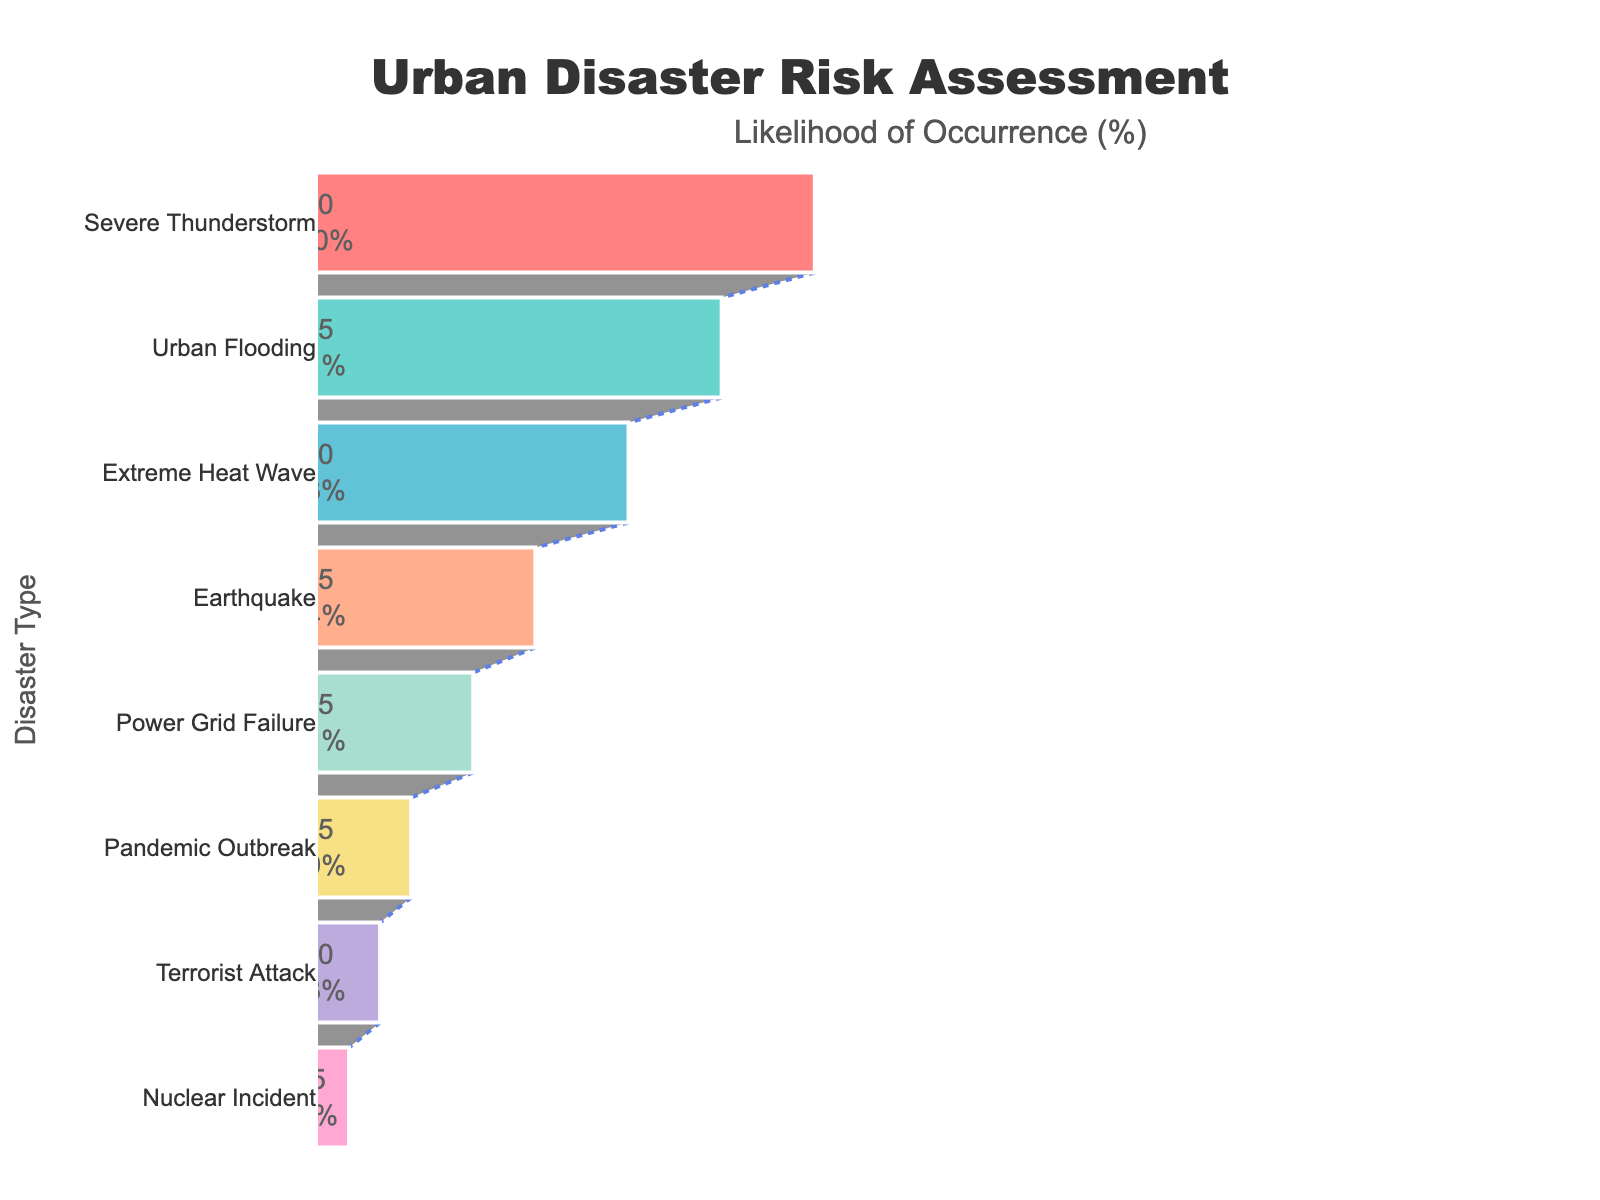What is the title of the funnel chart? The title is written at the top center of the chart.
Answer: Urban Disaster Risk Assessment What is the likelihood percentage for Severe Thunderstorm? The likelihood percentage is shown inside the funnel section for Severe Thunderstorm.
Answer: 80% How many disaster types are presented in the chart? Count the number of funnel sections, each representing a different disaster type.
Answer: 8 What is the average likelihood percentage of all disaster types? Sum all the likelihood percentages (80 + 65 + 50 + 35 + 25 + 15 + 10 + 5) and divide by the number of disaster types (8).
Answer: 35% What is the total likelihood percentage for Urban Flooding, Earthquake, and Pandemic Outbreak combined? Add the likelihood percentages for Urban Flooding (65), Earthquake (35), and Pandemic Outbreak (15).
Answer: 115% Which disaster type has a higher likelihood, Extreme Heat Wave or Power Grid Failure? Compare the likelihood percentages for Extreme Heat Wave (50) and Power Grid Failure (25).
Answer: Extreme Heat Wave Which event has the lowest likelihood percentage? Identify the event with the smallest likelihood percentage of 5.
Answer: Nuclear Incident Which disaster type is more likely to occur: Terrorist Attack or Earthquake? Compare the likelihood percentages for Terrorist Attack (10) and Earthquake (35).
Answer: Earthquake What percentage of the initial likelihood is accounted for by Severe Thunderstorm? Identify the percentage displayed inside the funnel section for Severe Thunderstorm, representing its share of the initial likelihood.
Answer: 80% What is the likelihood difference between the most and least likely disaster types? Subtract the likelihood percentage of the least likely disaster (Nuclear Incident, 5%) from the most likely disaster (Severe Thunderstorm, 80%).
Answer: 75% 